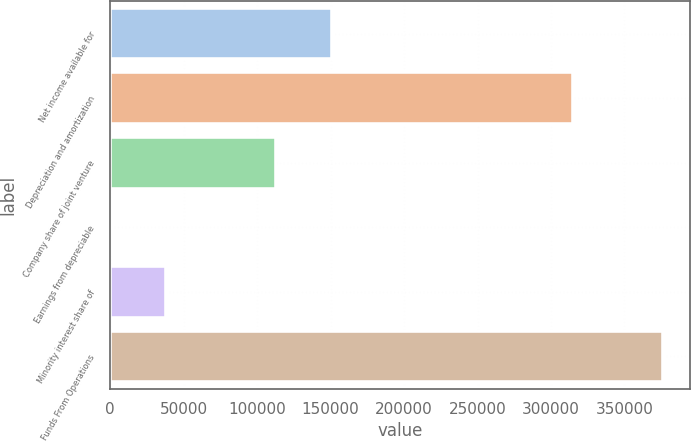Convert chart. <chart><loc_0><loc_0><loc_500><loc_500><bar_chart><fcel>Net income available for<fcel>Depreciation and amortization<fcel>Company share of joint venture<fcel>Earnings from depreciable<fcel>Minority interest share of<fcel>Funds From Operations<nl><fcel>150659<fcel>314952<fcel>113118<fcel>495<fcel>38036.1<fcel>375906<nl></chart> 